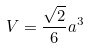<formula> <loc_0><loc_0><loc_500><loc_500>V = \frac { \sqrt { 2 } } { 6 } a ^ { 3 }</formula> 